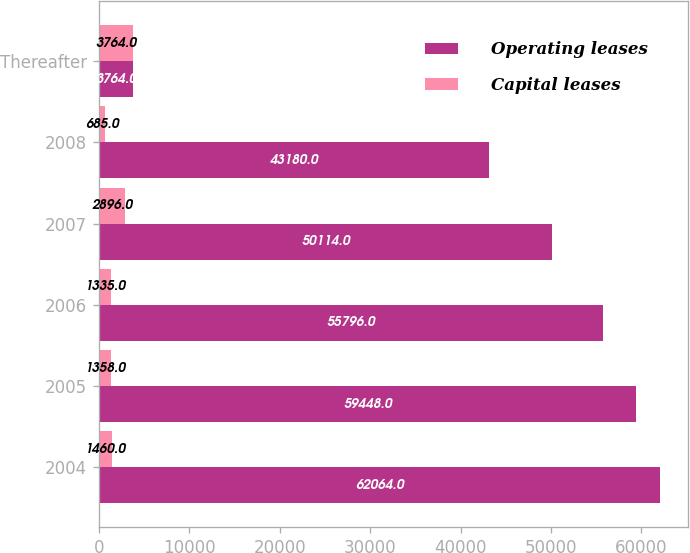Convert chart. <chart><loc_0><loc_0><loc_500><loc_500><stacked_bar_chart><ecel><fcel>2004<fcel>2005<fcel>2006<fcel>2007<fcel>2008<fcel>Thereafter<nl><fcel>Operating leases<fcel>62064<fcel>59448<fcel>55796<fcel>50114<fcel>43180<fcel>3764<nl><fcel>Capital leases<fcel>1460<fcel>1358<fcel>1335<fcel>2896<fcel>685<fcel>3764<nl></chart> 